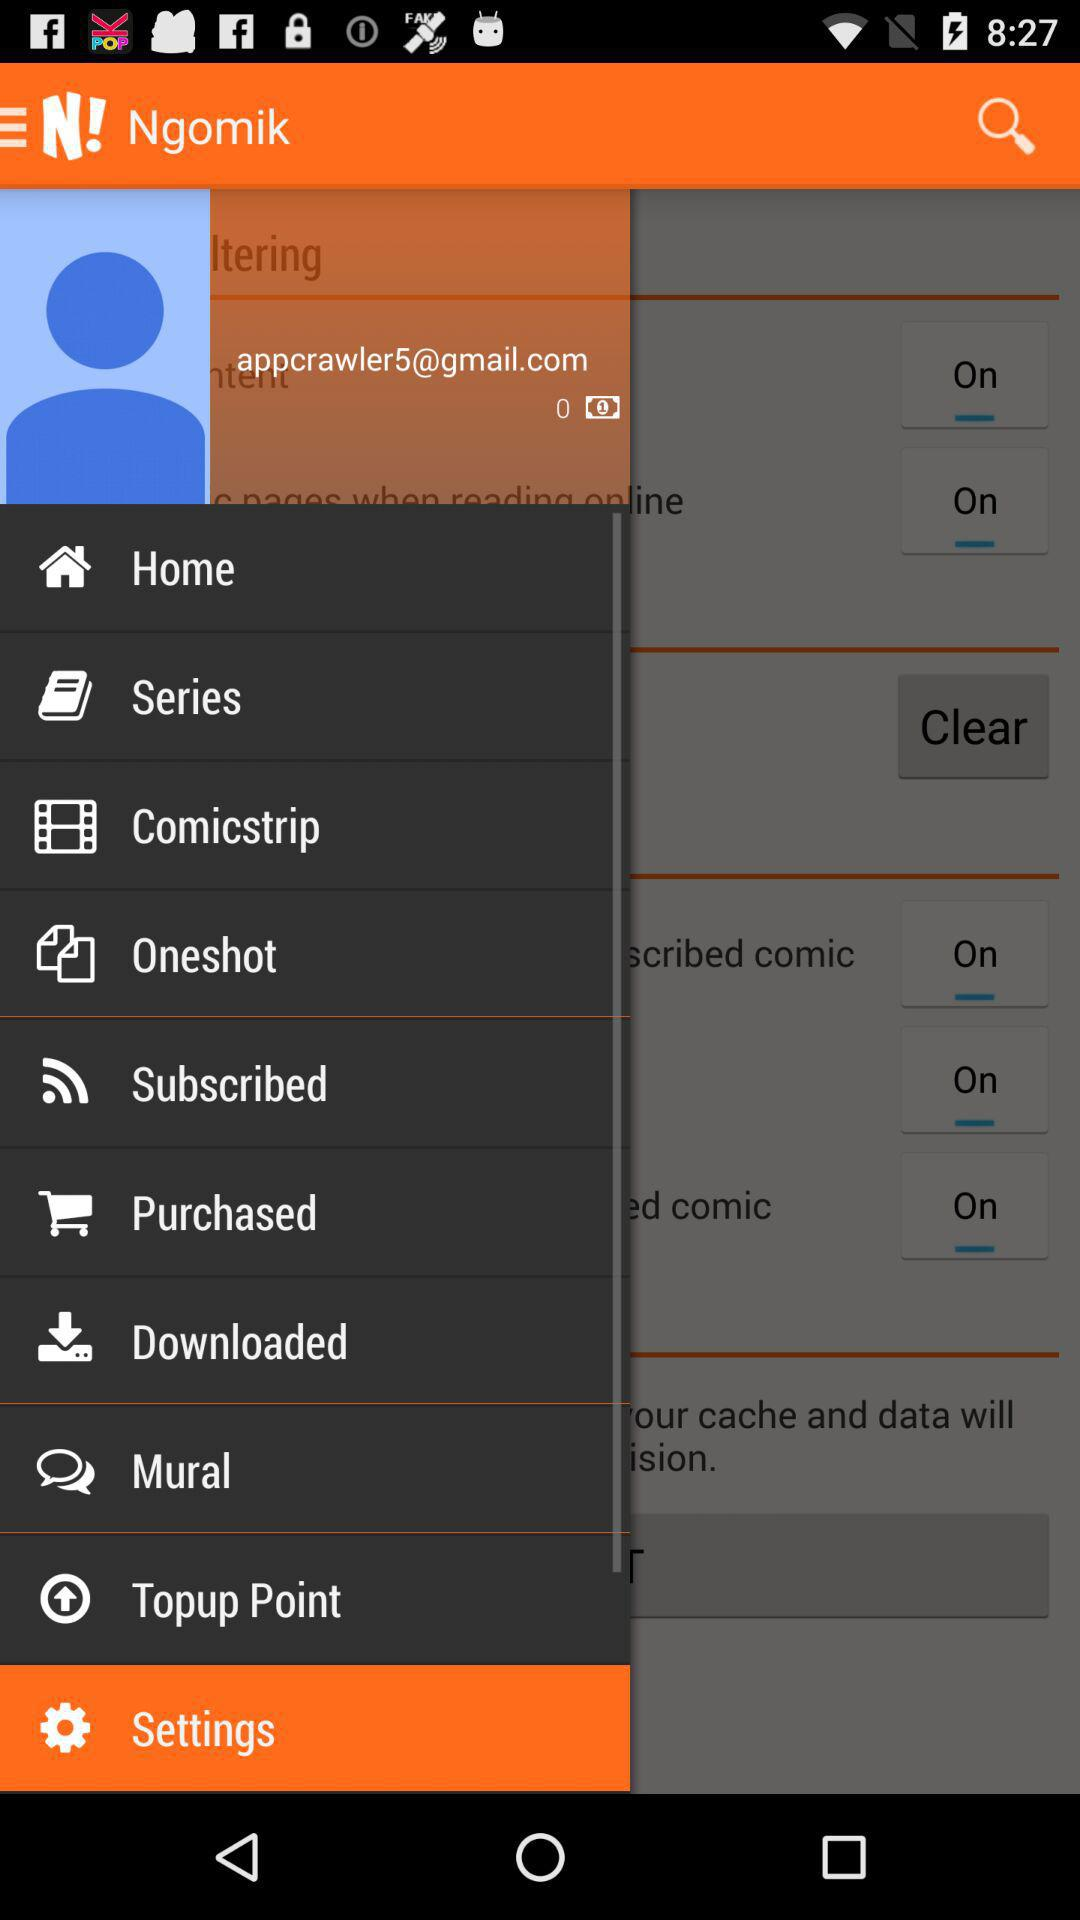What is the name of the application? The application name is "Ngomik". 